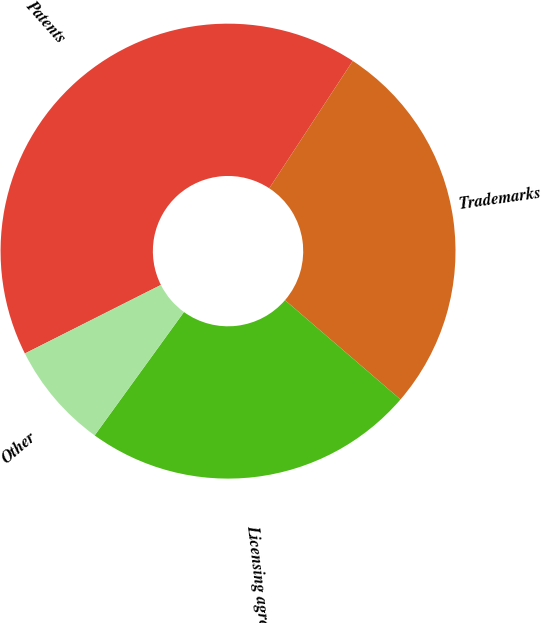<chart> <loc_0><loc_0><loc_500><loc_500><pie_chart><fcel>Patents<fcel>Trademarks<fcel>Licensing agreements<fcel>Other<nl><fcel>41.67%<fcel>27.07%<fcel>23.67%<fcel>7.6%<nl></chart> 